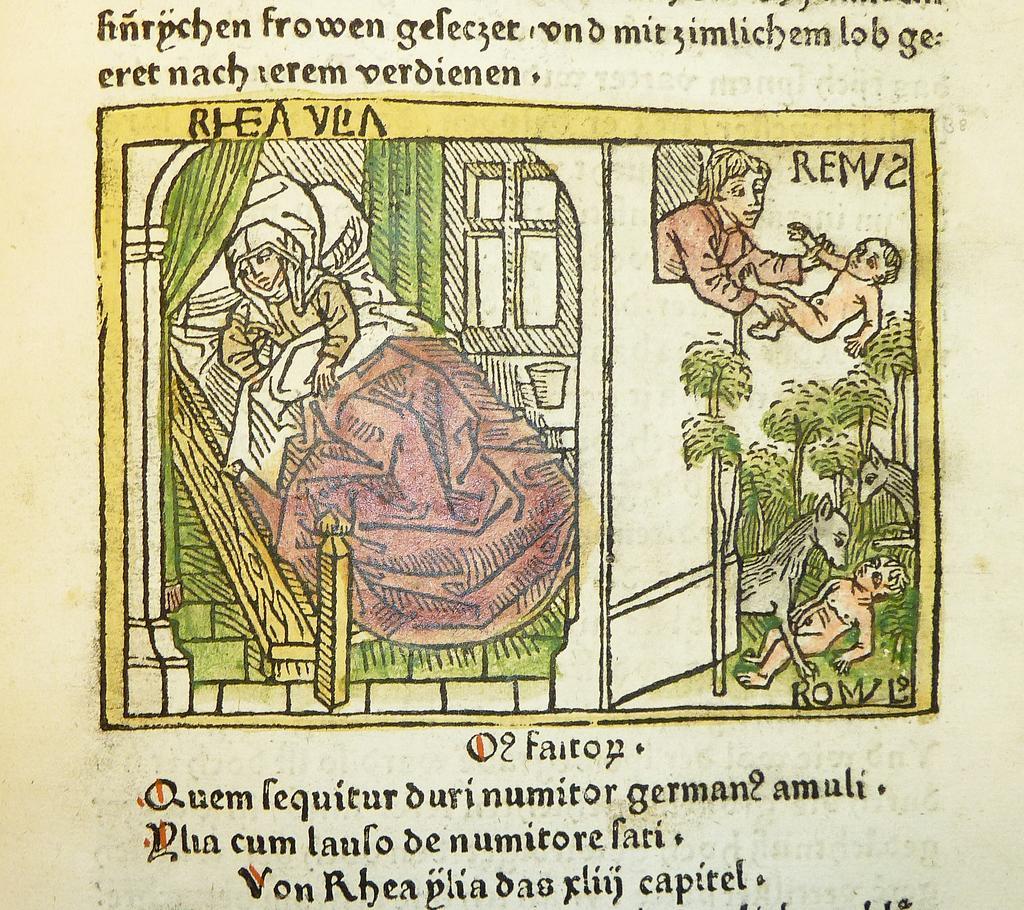Could you give a brief overview of what you see in this image? In this image I can see cartoon image of people, animal and trees. Here I can see some text. 